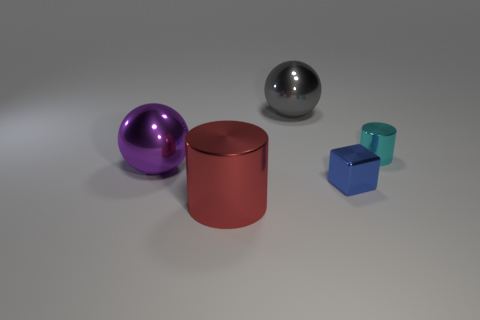What shape is the large red object that is the same material as the blue thing?
Give a very brief answer. Cylinder. Is the number of blue shiny cubes on the right side of the tiny cyan cylinder the same as the number of big metallic objects?
Make the answer very short. No. Is the material of the purple object that is on the left side of the big red object the same as the cylinder behind the tiny metal cube?
Provide a short and direct response. Yes. There is a large metal object behind the sphere that is on the left side of the big gray metallic ball; what shape is it?
Keep it short and to the point. Sphere. There is a small cylinder that is the same material as the blue thing; what color is it?
Your answer should be very brief. Cyan. Is the small cylinder the same color as the big cylinder?
Ensure brevity in your answer.  No. What shape is the gray thing that is the same size as the red metallic cylinder?
Ensure brevity in your answer.  Sphere. The gray metallic ball is what size?
Keep it short and to the point. Large. Does the shiny sphere that is behind the cyan metallic cylinder have the same size as the cyan shiny cylinder that is behind the big purple metal sphere?
Offer a terse response. No. What is the color of the sphere that is left of the thing that is in front of the cube?
Your response must be concise. Purple. 